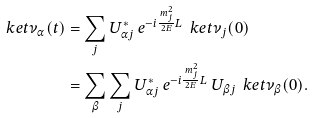<formula> <loc_0><loc_0><loc_500><loc_500>\ k e t { \nu _ { \alpha } ( t ) } & = \sum _ { j } U ^ { * } _ { \alpha j } \, e ^ { - i \frac { \, m ^ { 2 } _ { j } } { \, 2 E \, } L } \, \ k e t { \nu _ { j } ( 0 ) } \\ & = \sum _ { \beta } \sum _ { j } U ^ { * } _ { \alpha j } \, e ^ { - i \frac { \, m ^ { 2 } _ { j } } { \, 2 E \, } L } \, U _ { \beta j } \, \ k e t { \nu _ { \beta } ( 0 ) } . \\</formula> 